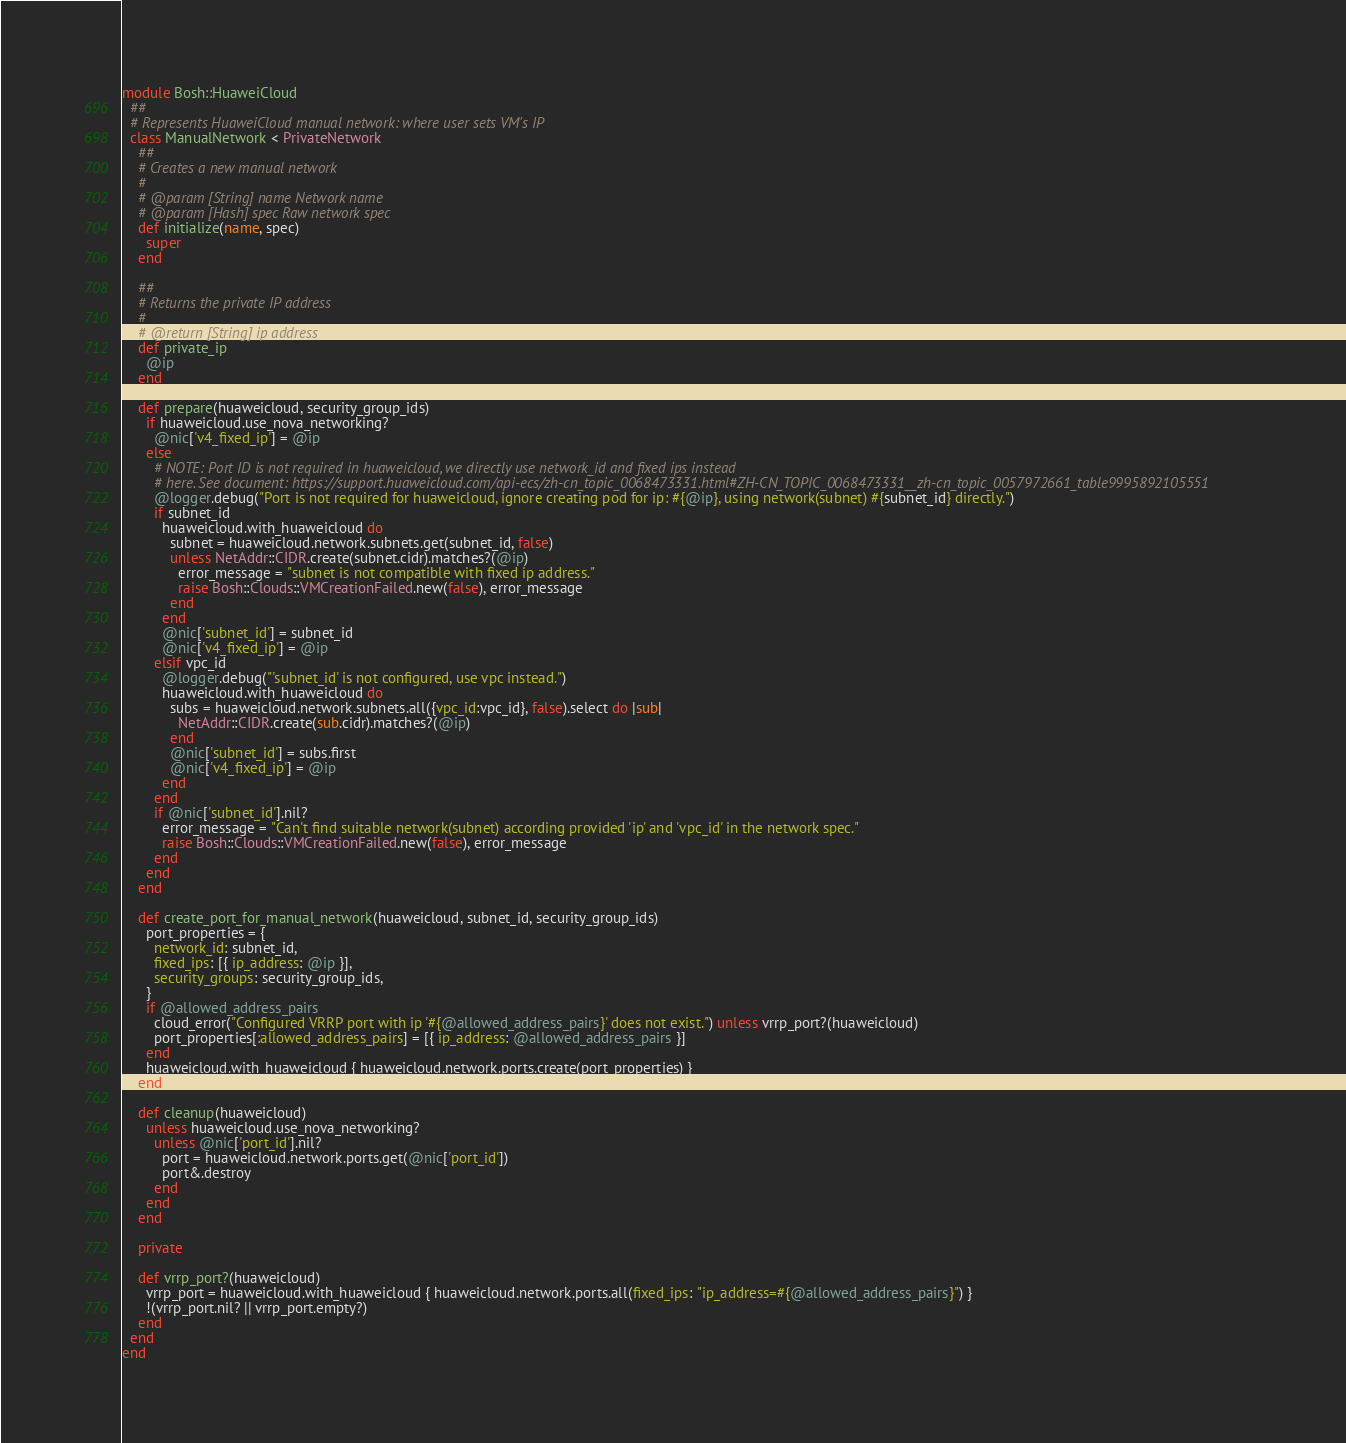Convert code to text. <code><loc_0><loc_0><loc_500><loc_500><_Ruby_>module Bosh::HuaweiCloud
  ##
  # Represents HuaweiCloud manual network: where user sets VM's IP
  class ManualNetwork < PrivateNetwork
    ##
    # Creates a new manual network
    #
    # @param [String] name Network name
    # @param [Hash] spec Raw network spec
    def initialize(name, spec)
      super
    end

    ##
    # Returns the private IP address
    #
    # @return [String] ip address
    def private_ip
      @ip
    end

    def prepare(huaweicloud, security_group_ids)
      if huaweicloud.use_nova_networking?
        @nic['v4_fixed_ip'] = @ip
      else
        # NOTE: Port ID is not required in huaweicloud, we directly use network_id and fixed ips instead
        # here. See document: https://support.huaweicloud.com/api-ecs/zh-cn_topic_0068473331.html#ZH-CN_TOPIC_0068473331__zh-cn_topic_0057972661_table9995892105551
        @logger.debug("Port is not required for huaweicloud, ignore creating pod for ip: #{@ip}, using network(subnet) #{subnet_id} directly.")
        if subnet_id
          huaweicloud.with_huaweicloud do
            subnet = huaweicloud.network.subnets.get(subnet_id, false)
            unless NetAddr::CIDR.create(subnet.cidr).matches?(@ip)
              error_message = "subnet is not compatible with fixed ip address."
              raise Bosh::Clouds::VMCreationFailed.new(false), error_message
            end
          end
          @nic['subnet_id'] = subnet_id
          @nic['v4_fixed_ip'] = @ip
        elsif vpc_id
          @logger.debug("'subnet_id' is not configured, use vpc instead.")
          huaweicloud.with_huaweicloud do
            subs = huaweicloud.network.subnets.all({vpc_id:vpc_id}, false).select do |sub|
              NetAddr::CIDR.create(sub.cidr).matches?(@ip)
            end
            @nic['subnet_id'] = subs.first
            @nic['v4_fixed_ip'] = @ip
          end
        end
        if @nic['subnet_id'].nil?
          error_message = "Can't find suitable network(subnet) according provided 'ip' and 'vpc_id' in the network spec."
          raise Bosh::Clouds::VMCreationFailed.new(false), error_message
        end
      end
    end

    def create_port_for_manual_network(huaweicloud, subnet_id, security_group_ids)
      port_properties = {
        network_id: subnet_id,
        fixed_ips: [{ ip_address: @ip }],
        security_groups: security_group_ids,
      }
      if @allowed_address_pairs
        cloud_error("Configured VRRP port with ip '#{@allowed_address_pairs}' does not exist.") unless vrrp_port?(huaweicloud)
        port_properties[:allowed_address_pairs] = [{ ip_address: @allowed_address_pairs }]
      end
      huaweicloud.with_huaweicloud { huaweicloud.network.ports.create(port_properties) }
    end

    def cleanup(huaweicloud)
      unless huaweicloud.use_nova_networking?
        unless @nic['port_id'].nil?
          port = huaweicloud.network.ports.get(@nic['port_id'])
          port&.destroy
        end
      end
    end

    private

    def vrrp_port?(huaweicloud)
      vrrp_port = huaweicloud.with_huaweicloud { huaweicloud.network.ports.all(fixed_ips: "ip_address=#{@allowed_address_pairs}") }
      !(vrrp_port.nil? || vrrp_port.empty?)
    end
  end
end
</code> 